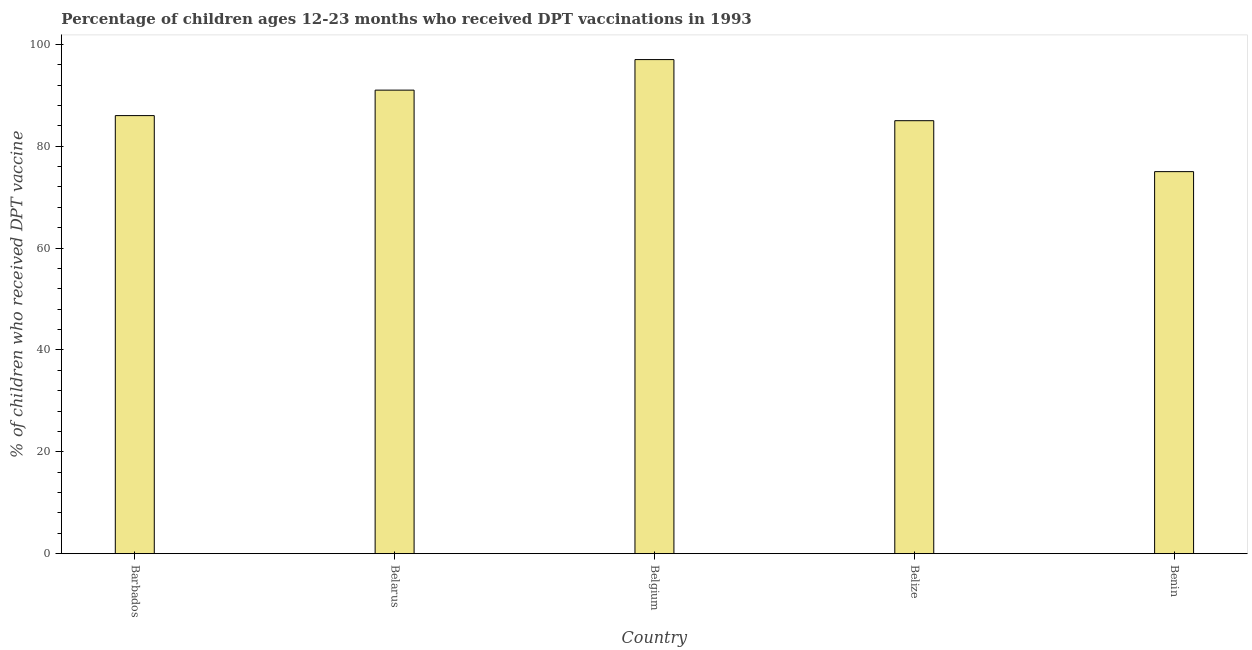Does the graph contain grids?
Your answer should be compact. No. What is the title of the graph?
Ensure brevity in your answer.  Percentage of children ages 12-23 months who received DPT vaccinations in 1993. What is the label or title of the X-axis?
Provide a short and direct response. Country. What is the label or title of the Y-axis?
Keep it short and to the point. % of children who received DPT vaccine. What is the percentage of children who received dpt vaccine in Benin?
Provide a short and direct response. 75. Across all countries, what is the maximum percentage of children who received dpt vaccine?
Ensure brevity in your answer.  97. Across all countries, what is the minimum percentage of children who received dpt vaccine?
Your answer should be very brief. 75. In which country was the percentage of children who received dpt vaccine maximum?
Offer a terse response. Belgium. In which country was the percentage of children who received dpt vaccine minimum?
Give a very brief answer. Benin. What is the sum of the percentage of children who received dpt vaccine?
Your answer should be very brief. 434. What is the difference between the percentage of children who received dpt vaccine in Barbados and Benin?
Provide a short and direct response. 11. What is the average percentage of children who received dpt vaccine per country?
Your answer should be compact. 86.8. What is the median percentage of children who received dpt vaccine?
Your answer should be very brief. 86. What is the ratio of the percentage of children who received dpt vaccine in Barbados to that in Belgium?
Provide a succinct answer. 0.89. What is the difference between the highest and the second highest percentage of children who received dpt vaccine?
Provide a short and direct response. 6. Is the sum of the percentage of children who received dpt vaccine in Barbados and Benin greater than the maximum percentage of children who received dpt vaccine across all countries?
Provide a succinct answer. Yes. What is the difference between the highest and the lowest percentage of children who received dpt vaccine?
Provide a short and direct response. 22. What is the difference between two consecutive major ticks on the Y-axis?
Make the answer very short. 20. What is the % of children who received DPT vaccine of Belarus?
Offer a terse response. 91. What is the % of children who received DPT vaccine in Belgium?
Offer a very short reply. 97. What is the difference between the % of children who received DPT vaccine in Barbados and Belarus?
Make the answer very short. -5. What is the difference between the % of children who received DPT vaccine in Barbados and Belize?
Provide a succinct answer. 1. What is the difference between the % of children who received DPT vaccine in Belarus and Belize?
Offer a terse response. 6. What is the difference between the % of children who received DPT vaccine in Belarus and Benin?
Your answer should be very brief. 16. What is the difference between the % of children who received DPT vaccine in Belize and Benin?
Ensure brevity in your answer.  10. What is the ratio of the % of children who received DPT vaccine in Barbados to that in Belarus?
Your answer should be compact. 0.94. What is the ratio of the % of children who received DPT vaccine in Barbados to that in Belgium?
Your answer should be compact. 0.89. What is the ratio of the % of children who received DPT vaccine in Barbados to that in Belize?
Offer a terse response. 1.01. What is the ratio of the % of children who received DPT vaccine in Barbados to that in Benin?
Provide a short and direct response. 1.15. What is the ratio of the % of children who received DPT vaccine in Belarus to that in Belgium?
Provide a short and direct response. 0.94. What is the ratio of the % of children who received DPT vaccine in Belarus to that in Belize?
Give a very brief answer. 1.07. What is the ratio of the % of children who received DPT vaccine in Belarus to that in Benin?
Your answer should be compact. 1.21. What is the ratio of the % of children who received DPT vaccine in Belgium to that in Belize?
Provide a short and direct response. 1.14. What is the ratio of the % of children who received DPT vaccine in Belgium to that in Benin?
Your response must be concise. 1.29. What is the ratio of the % of children who received DPT vaccine in Belize to that in Benin?
Your answer should be compact. 1.13. 